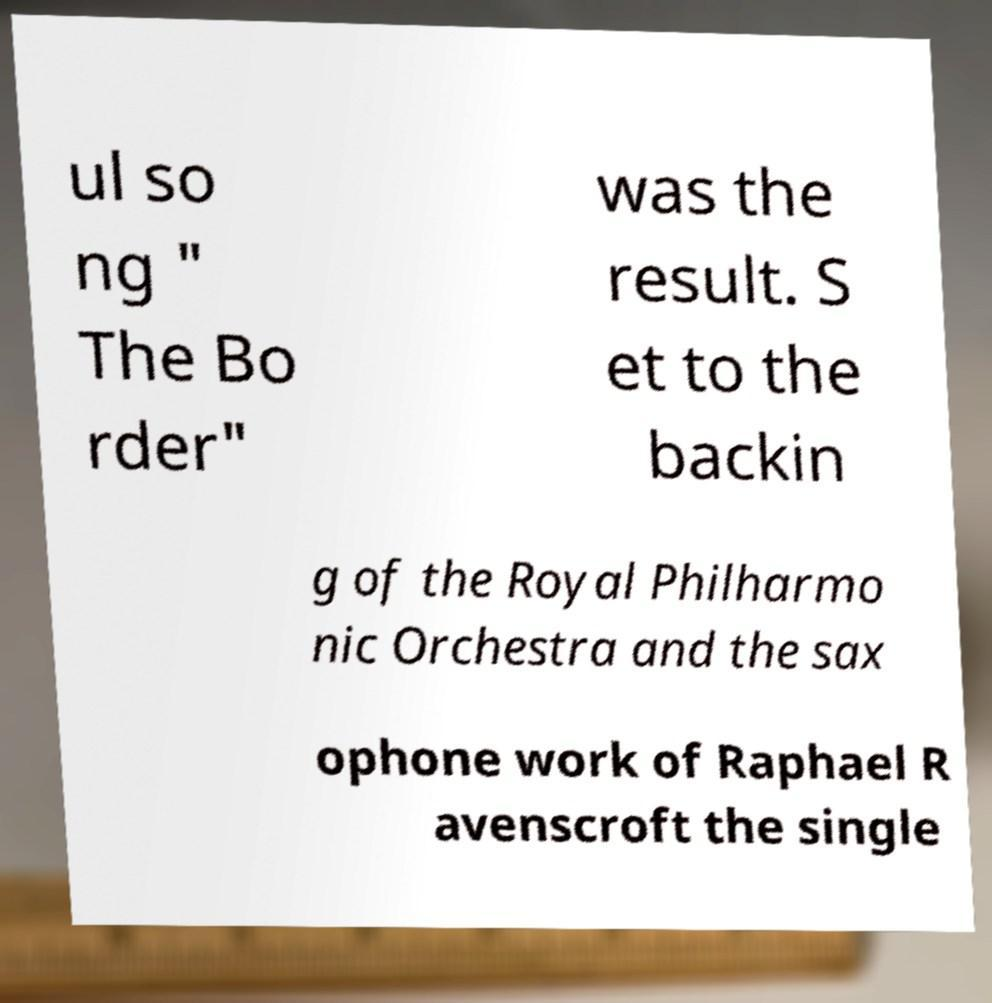Please read and relay the text visible in this image. What does it say? ul so ng " The Bo rder" was the result. S et to the backin g of the Royal Philharmo nic Orchestra and the sax ophone work of Raphael R avenscroft the single 